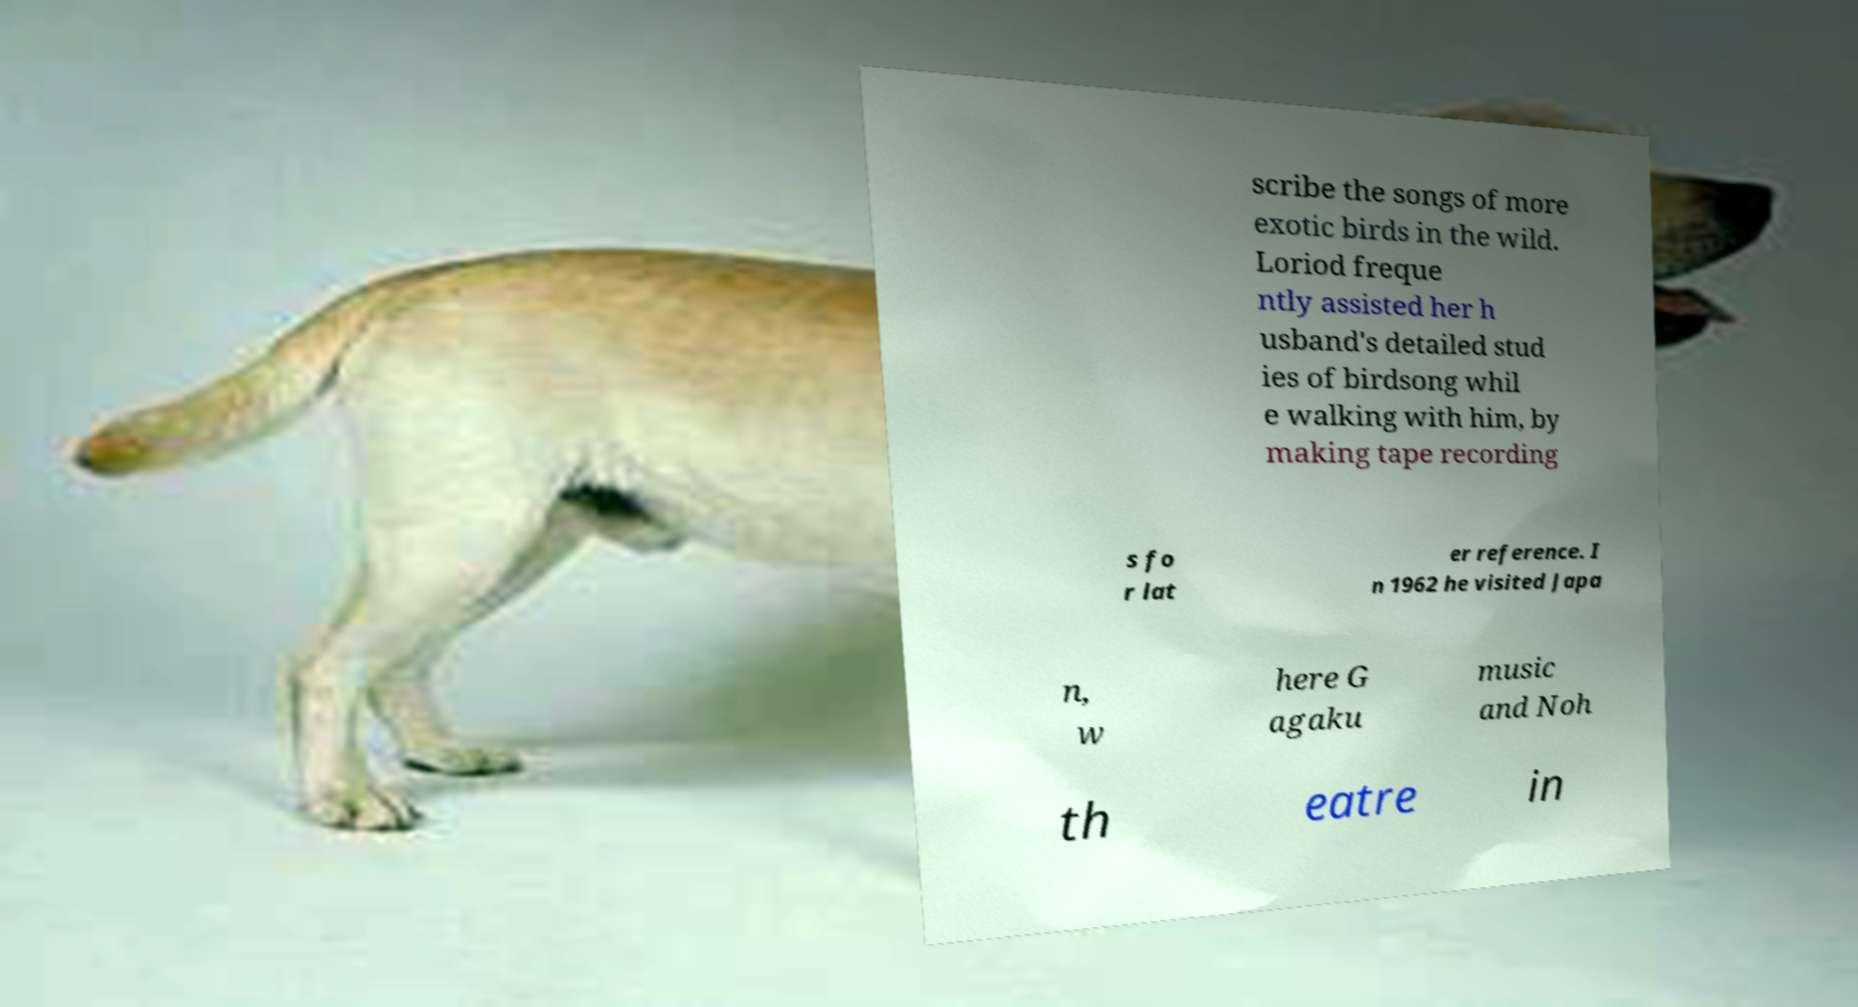Can you read and provide the text displayed in the image?This photo seems to have some interesting text. Can you extract and type it out for me? scribe the songs of more exotic birds in the wild. Loriod freque ntly assisted her h usband's detailed stud ies of birdsong whil e walking with him, by making tape recording s fo r lat er reference. I n 1962 he visited Japa n, w here G agaku music and Noh th eatre in 